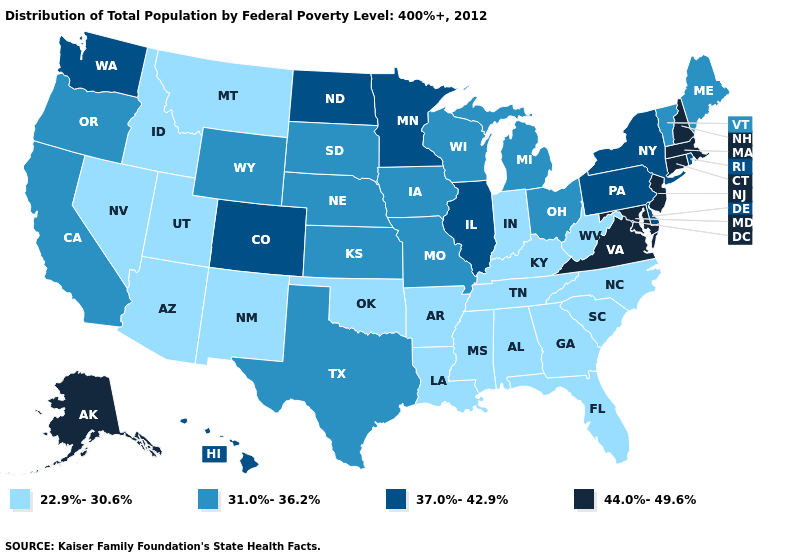Name the states that have a value in the range 31.0%-36.2%?
Write a very short answer. California, Iowa, Kansas, Maine, Michigan, Missouri, Nebraska, Ohio, Oregon, South Dakota, Texas, Vermont, Wisconsin, Wyoming. Which states hav the highest value in the West?
Answer briefly. Alaska. Among the states that border Delaware , which have the highest value?
Short answer required. Maryland, New Jersey. Does South Carolina have a higher value than Wisconsin?
Short answer required. No. What is the value of Minnesota?
Give a very brief answer. 37.0%-42.9%. Which states hav the highest value in the MidWest?
Quick response, please. Illinois, Minnesota, North Dakota. Which states have the lowest value in the Northeast?
Quick response, please. Maine, Vermont. What is the value of Nebraska?
Give a very brief answer. 31.0%-36.2%. What is the lowest value in states that border Arizona?
Concise answer only. 22.9%-30.6%. Is the legend a continuous bar?
Keep it brief. No. Name the states that have a value in the range 44.0%-49.6%?
Write a very short answer. Alaska, Connecticut, Maryland, Massachusetts, New Hampshire, New Jersey, Virginia. Among the states that border Indiana , does Illinois have the highest value?
Keep it brief. Yes. Name the states that have a value in the range 22.9%-30.6%?
Answer briefly. Alabama, Arizona, Arkansas, Florida, Georgia, Idaho, Indiana, Kentucky, Louisiana, Mississippi, Montana, Nevada, New Mexico, North Carolina, Oklahoma, South Carolina, Tennessee, Utah, West Virginia. What is the value of North Carolina?
Quick response, please. 22.9%-30.6%. 